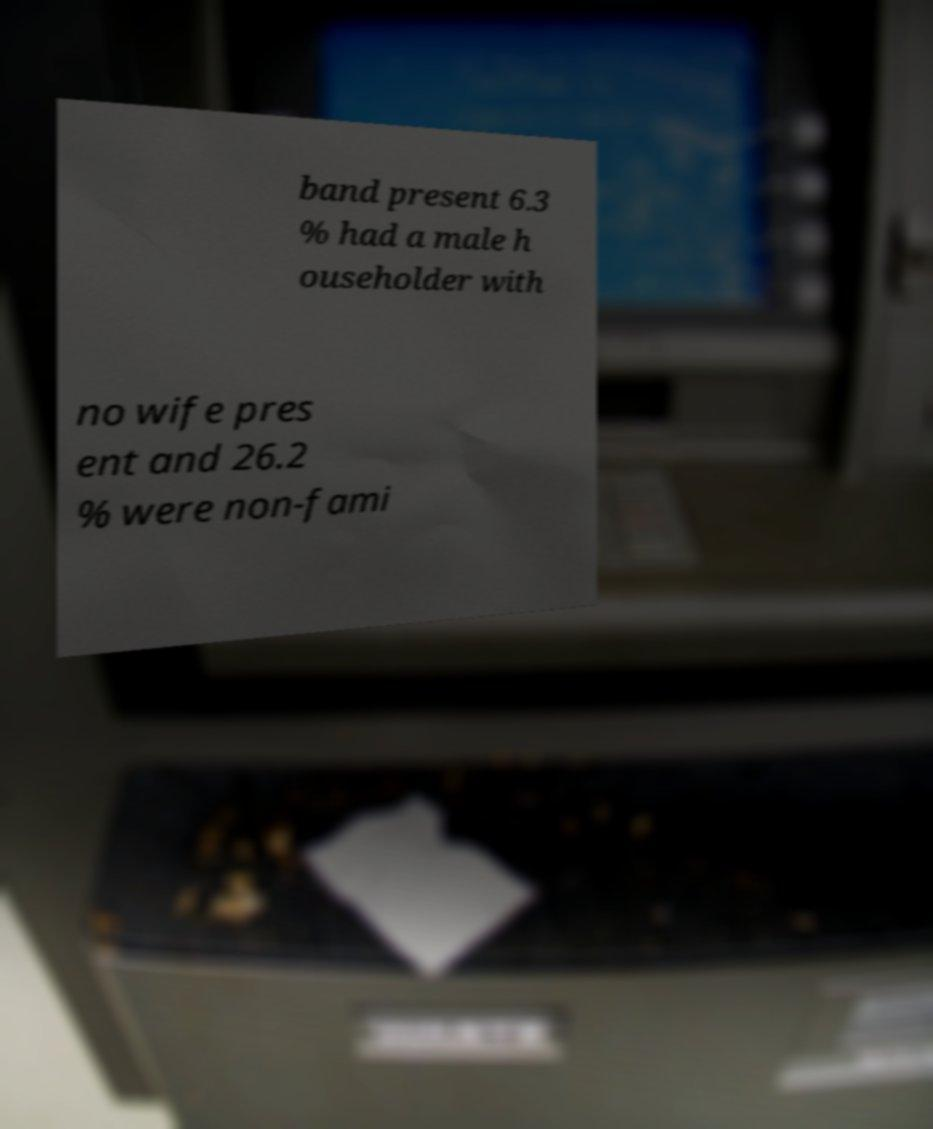Could you assist in decoding the text presented in this image and type it out clearly? band present 6.3 % had a male h ouseholder with no wife pres ent and 26.2 % were non-fami 